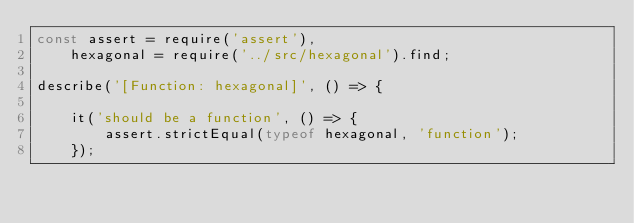<code> <loc_0><loc_0><loc_500><loc_500><_JavaScript_>const assert = require('assert'),
	hexagonal = require('../src/hexagonal').find;

describe('[Function: hexagonal]', () => {

	it('should be a function', () => {
		assert.strictEqual(typeof hexagonal, 'function');
	});
</code> 